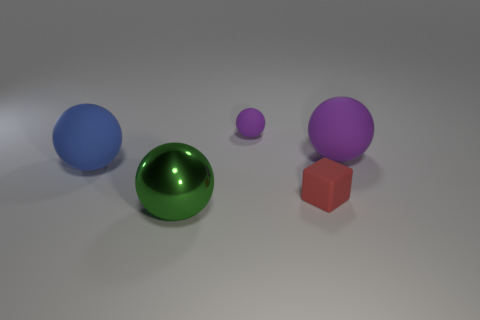What does the arrangement of these objects tell us about the spatial composition of the image? The spatial composition is balanced yet dynamic. The objects are placed at varying distances from each other, which creates depth. Their different colors add interest, and the variation in size draws the eye across the image, indicating that each object's placement was thoughtfully considered to build a harmonious scene. 